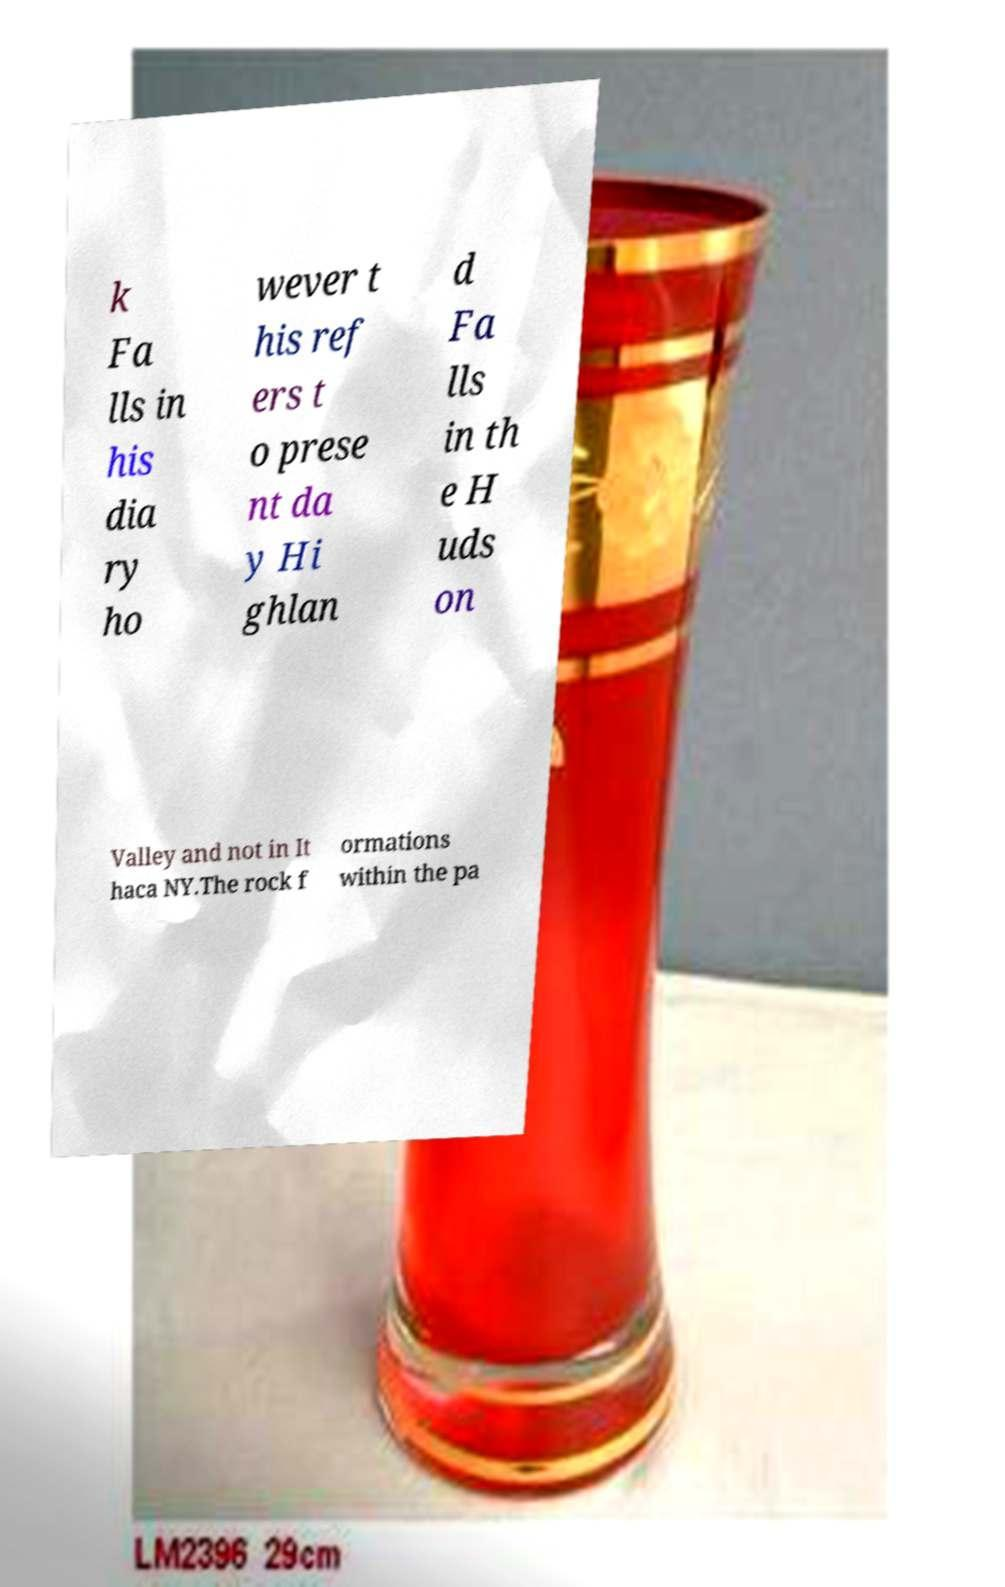For documentation purposes, I need the text within this image transcribed. Could you provide that? k Fa lls in his dia ry ho wever t his ref ers t o prese nt da y Hi ghlan d Fa lls in th e H uds on Valley and not in It haca NY.The rock f ormations within the pa 